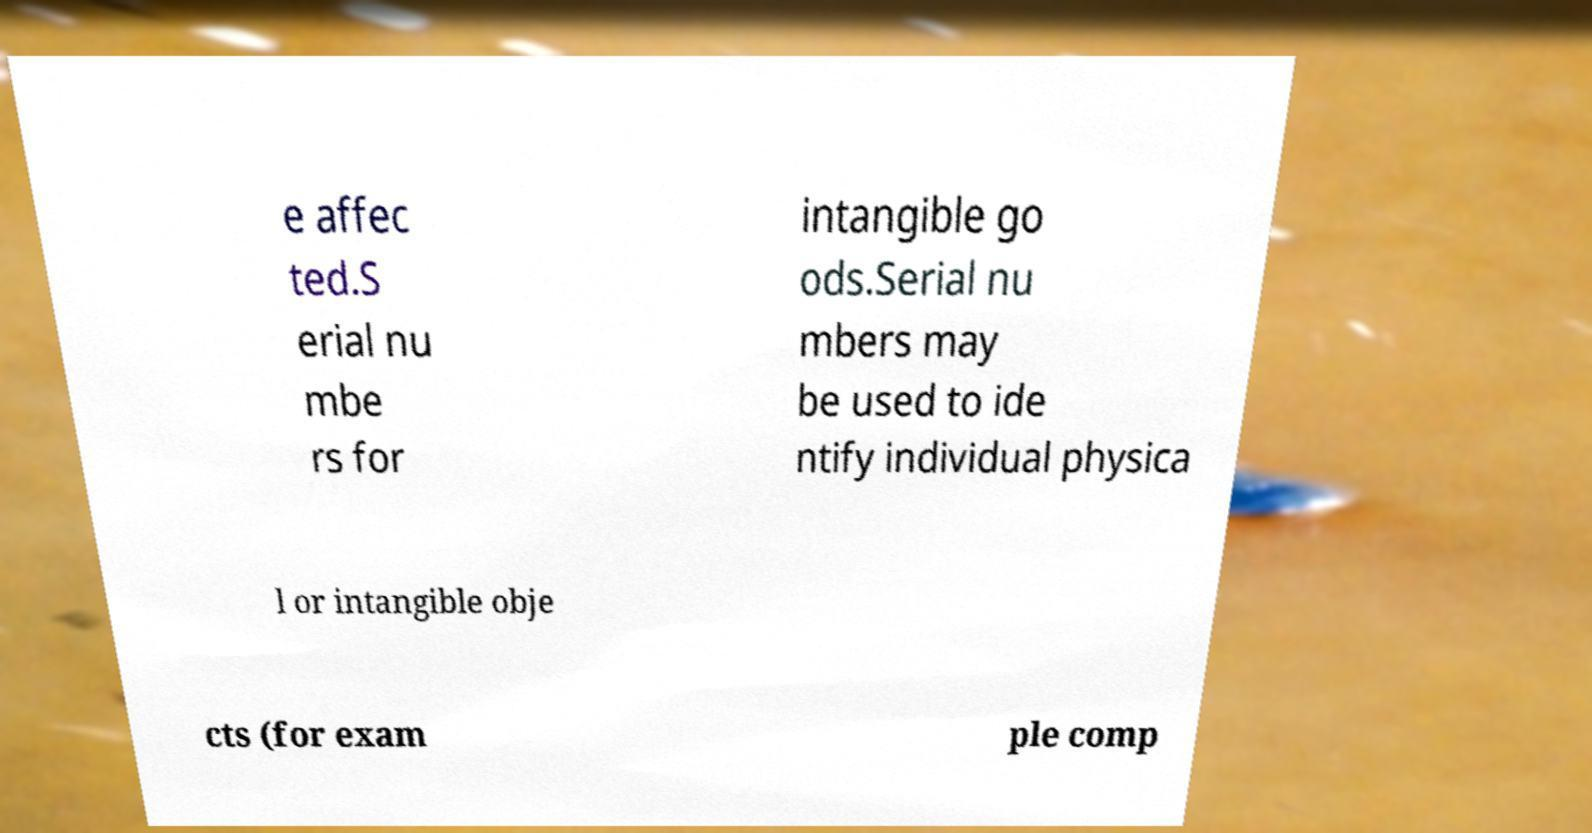For documentation purposes, I need the text within this image transcribed. Could you provide that? e affec ted.S erial nu mbe rs for intangible go ods.Serial nu mbers may be used to ide ntify individual physica l or intangible obje cts (for exam ple comp 